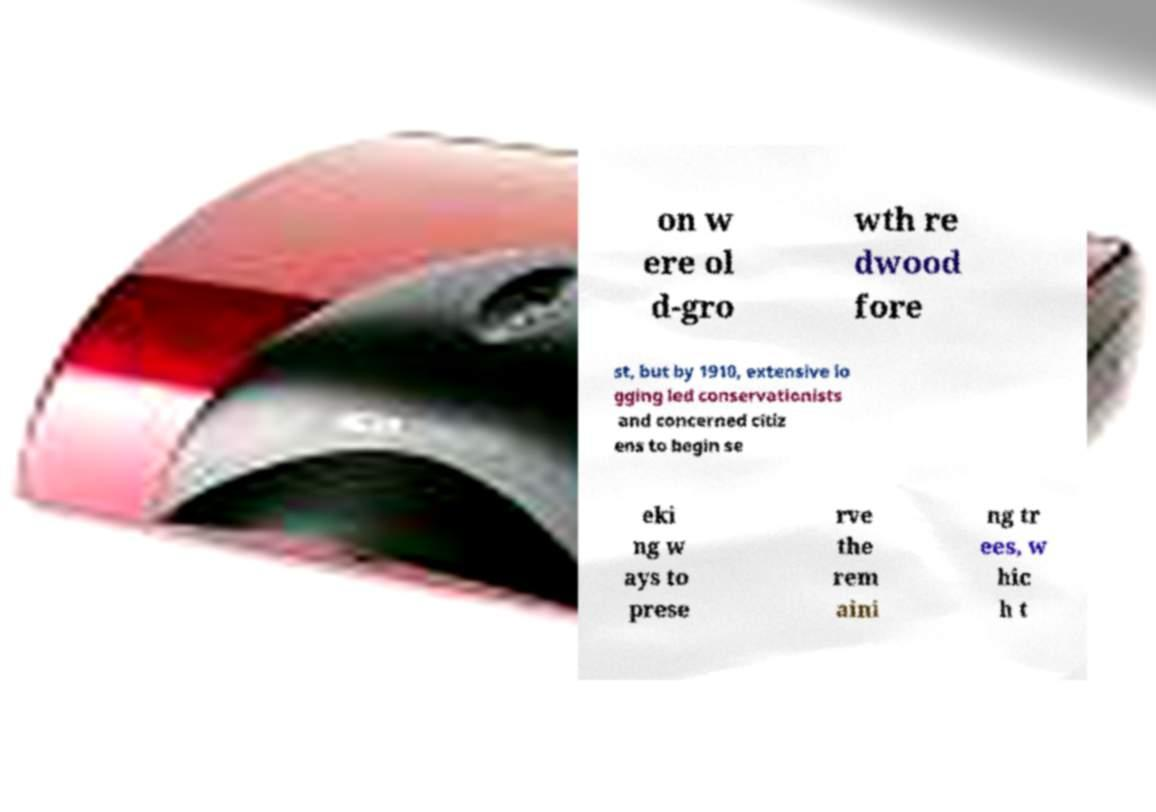What messages or text are displayed in this image? I need them in a readable, typed format. on w ere ol d-gro wth re dwood fore st, but by 1910, extensive lo gging led conservationists and concerned citiz ens to begin se eki ng w ays to prese rve the rem aini ng tr ees, w hic h t 